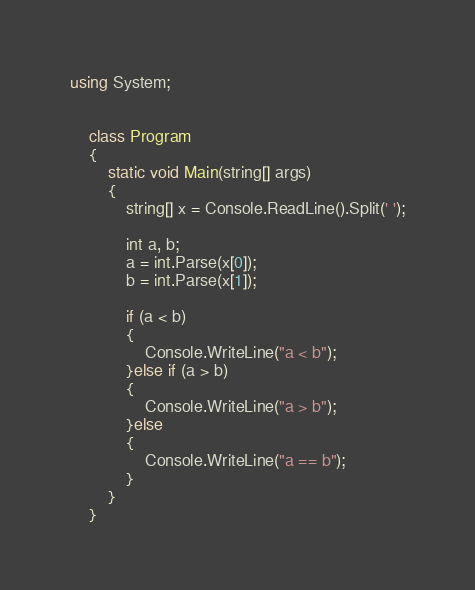Convert code to text. <code><loc_0><loc_0><loc_500><loc_500><_C#_>using System;


    class Program
    {
        static void Main(string[] args)
        {
            string[] x = Console.ReadLine().Split(' ');

            int a, b;
            a = int.Parse(x[0]);
            b = int.Parse(x[1]);

            if (a < b)
            {
                Console.WriteLine("a < b");
            }else if (a > b)
            {
                Console.WriteLine("a > b");
            }else
            {
                Console.WriteLine("a == b");
            }
        }
    }


</code> 